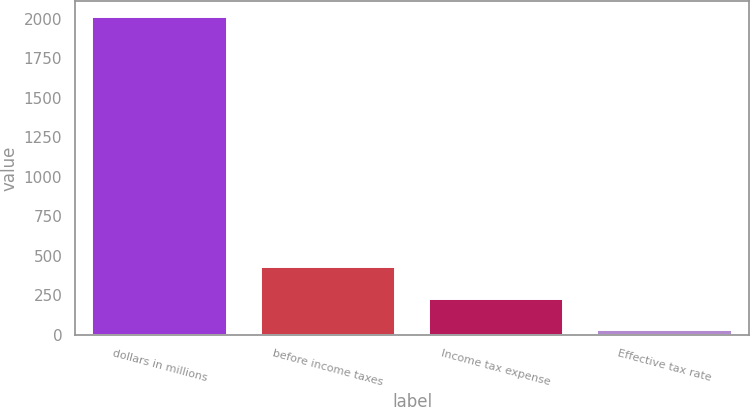Convert chart. <chart><loc_0><loc_0><loc_500><loc_500><bar_chart><fcel>dollars in millions<fcel>before income taxes<fcel>Income tax expense<fcel>Effective tax rate<nl><fcel>2014<fcel>427.36<fcel>229.03<fcel>30.7<nl></chart> 